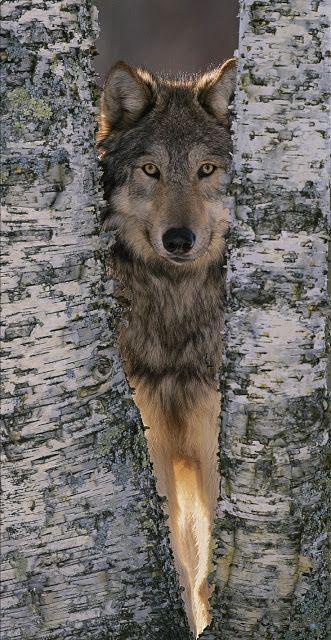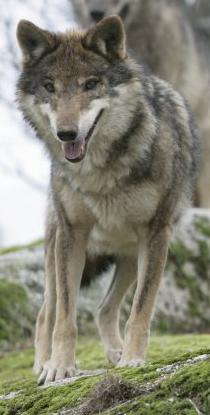The first image is the image on the left, the second image is the image on the right. Considering the images on both sides, is "One image contains twice as many wolves as the other image." valid? Answer yes or no. No. The first image is the image on the left, the second image is the image on the right. Examine the images to the left and right. Is the description "Two wolves are hanging out together in one of the pictures." accurate? Answer yes or no. No. 